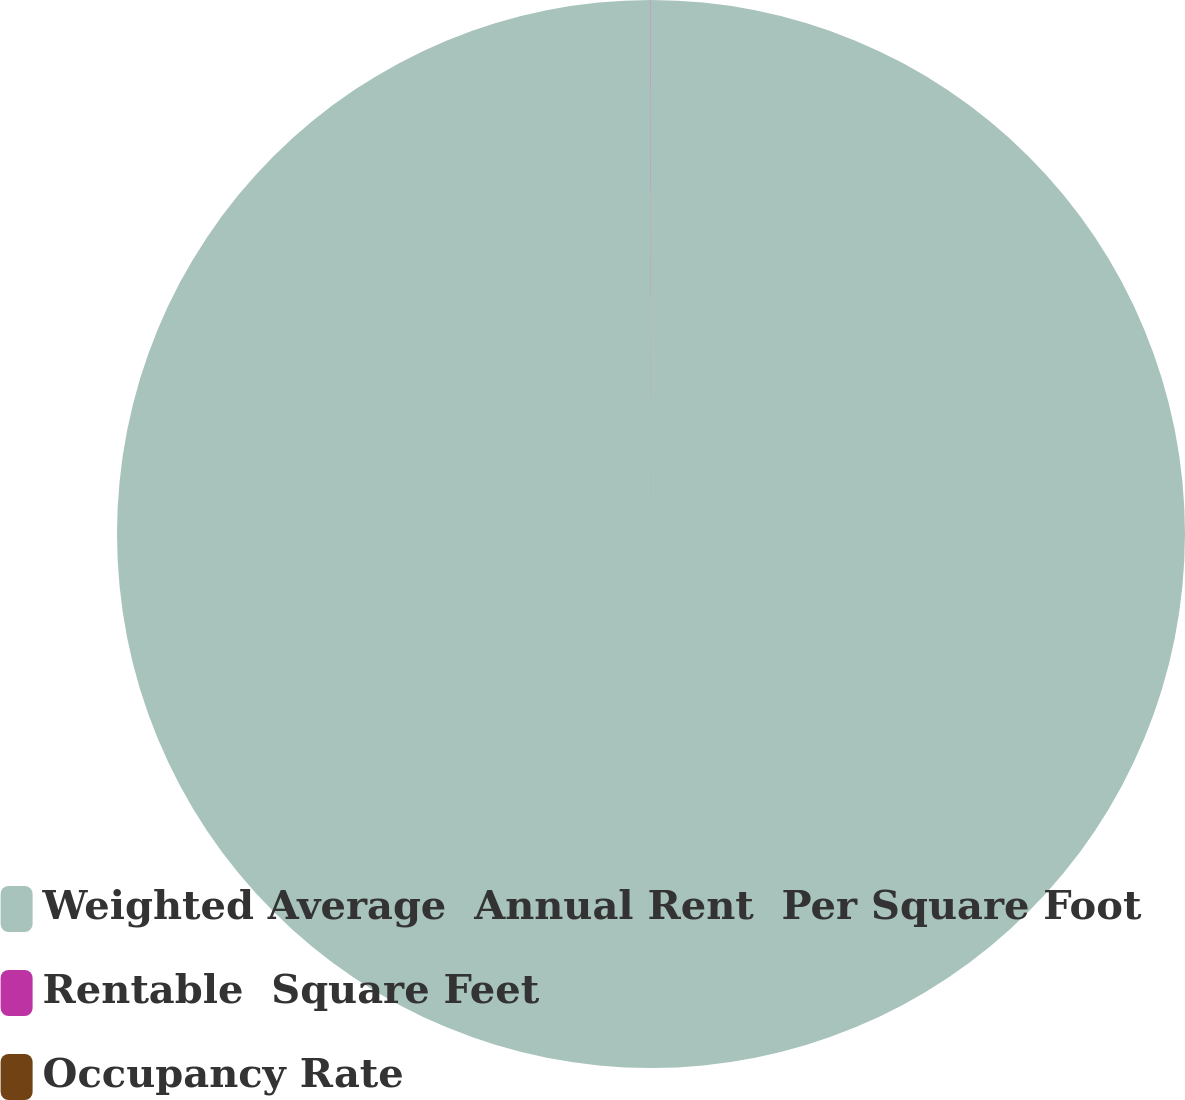Convert chart. <chart><loc_0><loc_0><loc_500><loc_500><pie_chart><fcel>Weighted Average  Annual Rent  Per Square Foot<fcel>Rentable  Square Feet<fcel>Occupancy Rate<nl><fcel>99.99%<fcel>0.01%<fcel>0.0%<nl></chart> 